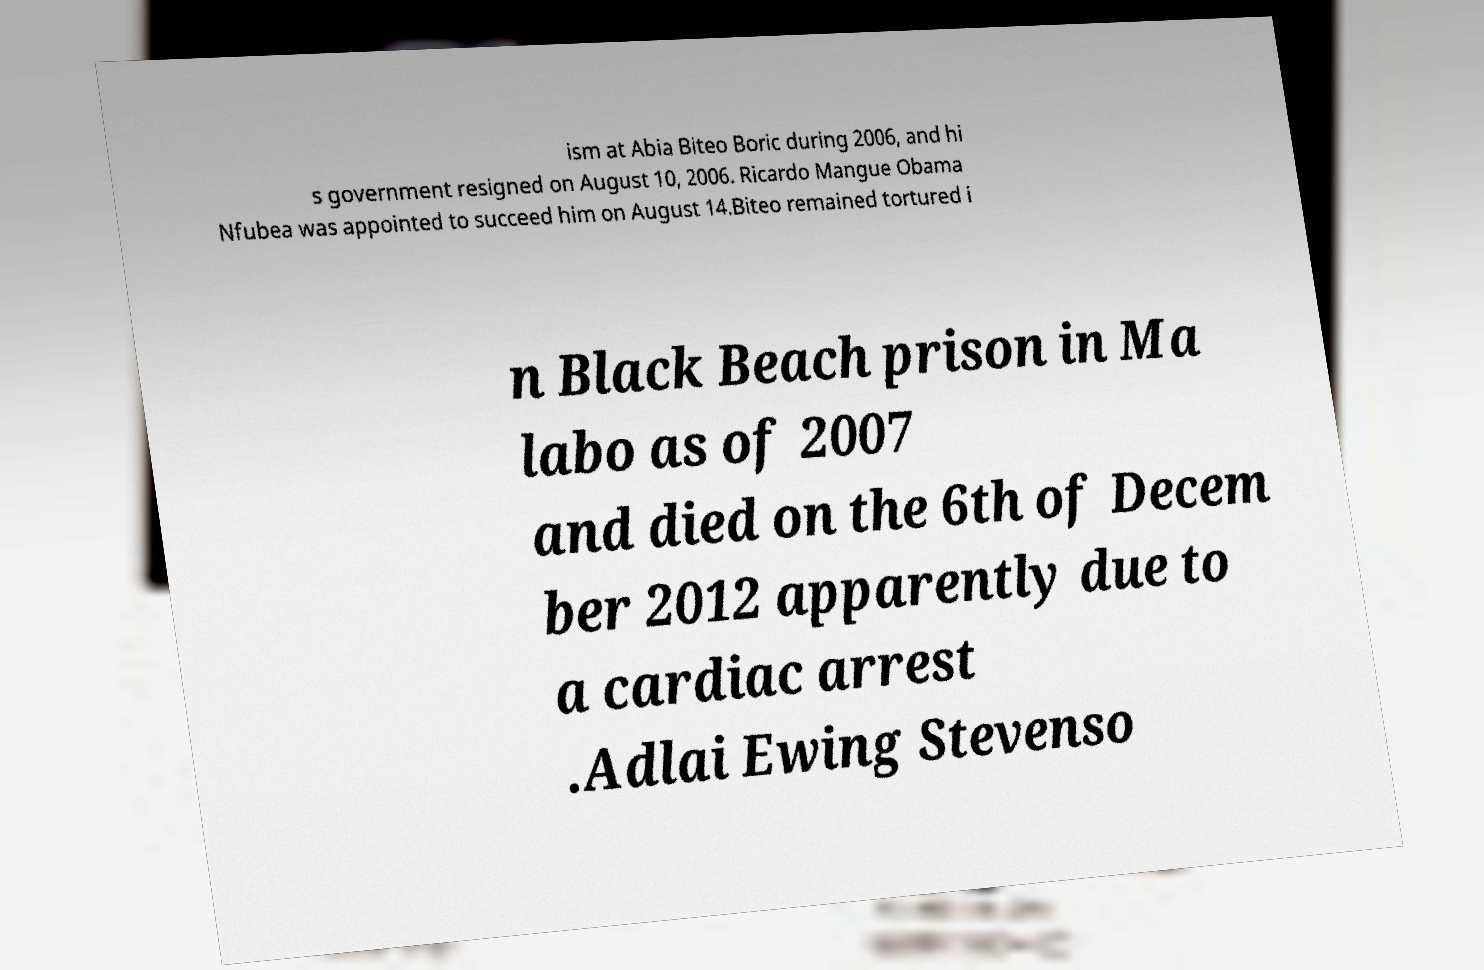Please read and relay the text visible in this image. What does it say? ism at Abia Biteo Boric during 2006, and hi s government resigned on August 10, 2006. Ricardo Mangue Obama Nfubea was appointed to succeed him on August 14.Biteo remained tortured i n Black Beach prison in Ma labo as of 2007 and died on the 6th of Decem ber 2012 apparently due to a cardiac arrest .Adlai Ewing Stevenso 